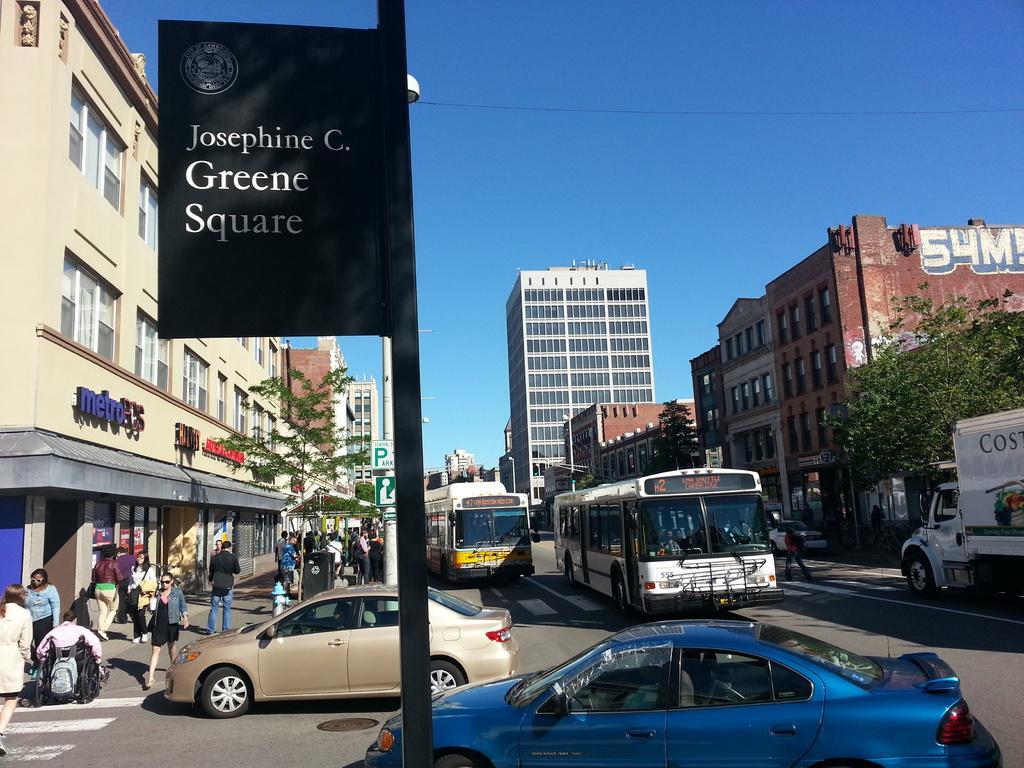Can you describe this image briefly? In this picture we can see vehicles and people on the road, here we can see buildings, trees, boards and in the background we can see the sky. 